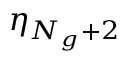Convert formula to latex. <formula><loc_0><loc_0><loc_500><loc_500>\eta _ { N _ { g } + 2 }</formula> 